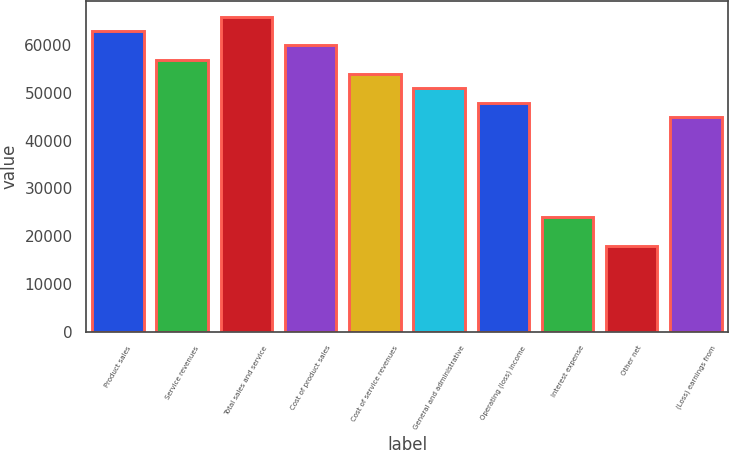<chart> <loc_0><loc_0><loc_500><loc_500><bar_chart><fcel>Product sales<fcel>Service revenues<fcel>Total sales and service<fcel>Cost of product sales<fcel>Cost of service revenues<fcel>General and administrative<fcel>Operating (loss) income<fcel>Interest expense<fcel>Other net<fcel>(Loss) earnings from<nl><fcel>62980.9<fcel>56982.8<fcel>65980<fcel>59981.8<fcel>53983.7<fcel>50984.6<fcel>47985.5<fcel>23992.8<fcel>17994.7<fcel>44986.4<nl></chart> 